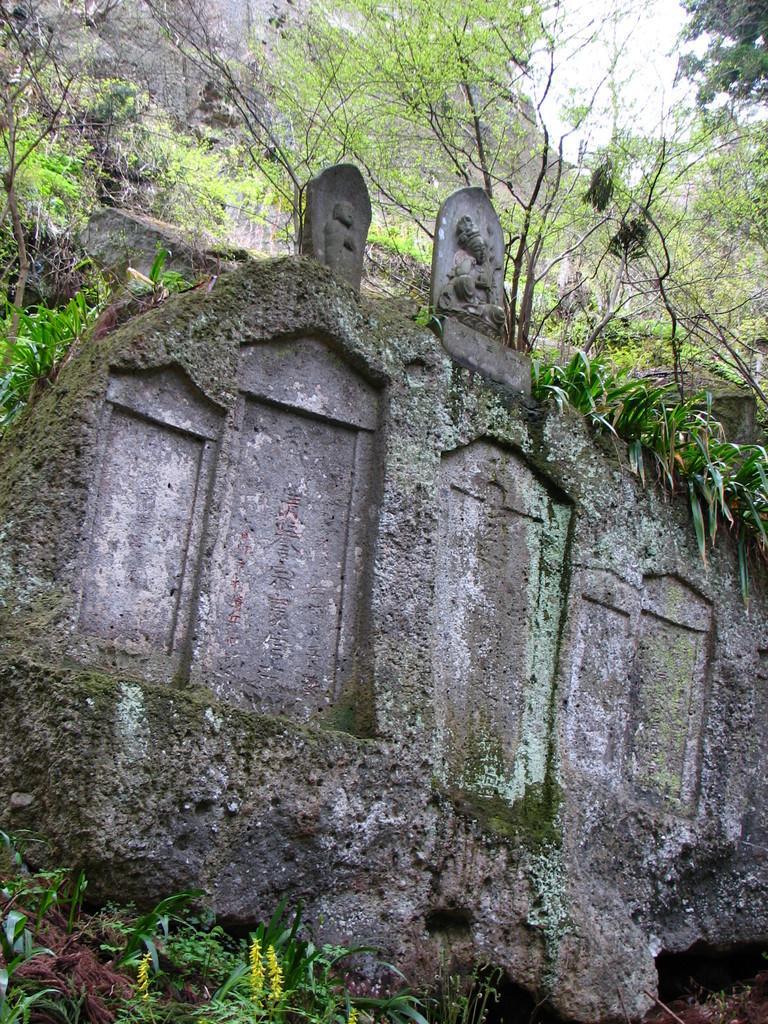Can you describe this image briefly? In this image we can see a wall, statue on the wall and in the background there are few trees, a mountain and sky. 